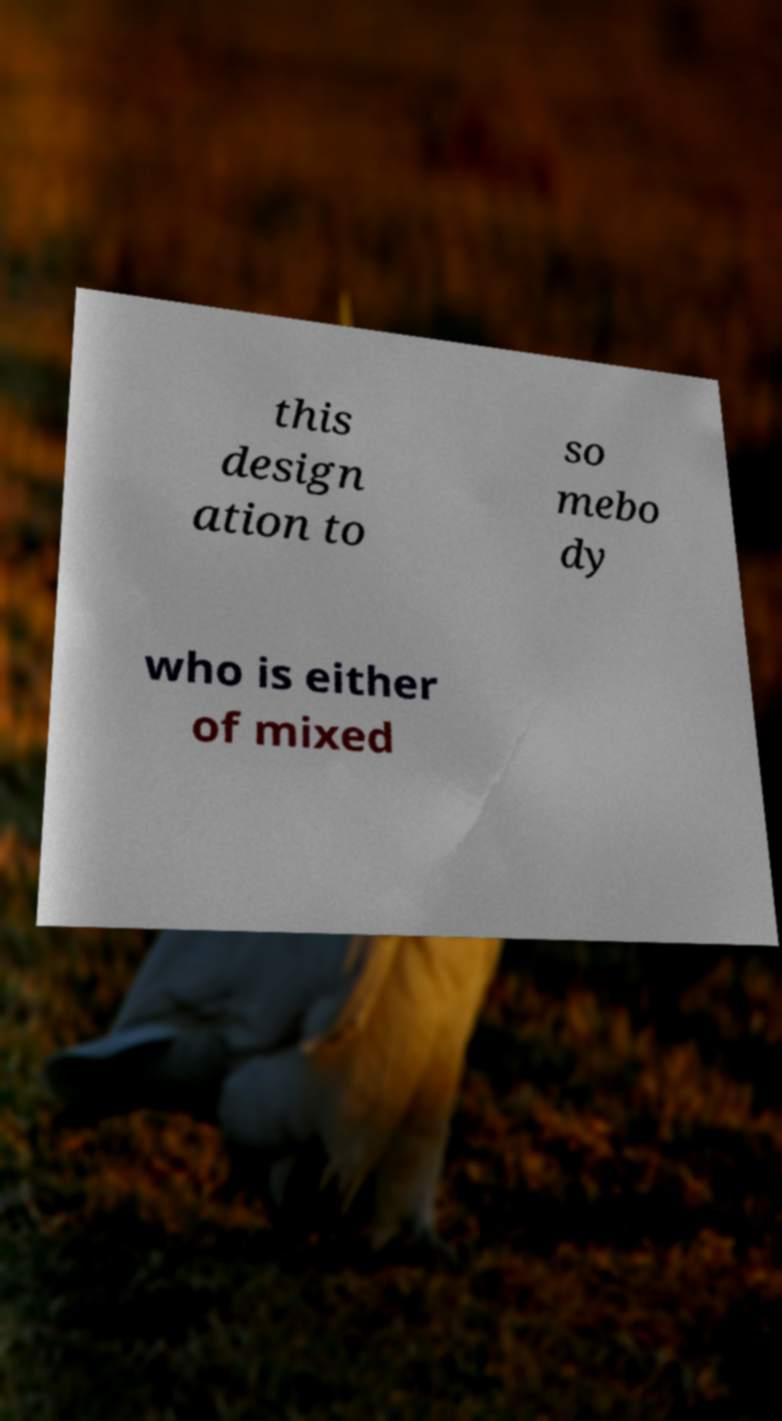What messages or text are displayed in this image? I need them in a readable, typed format. this design ation to so mebo dy who is either of mixed 